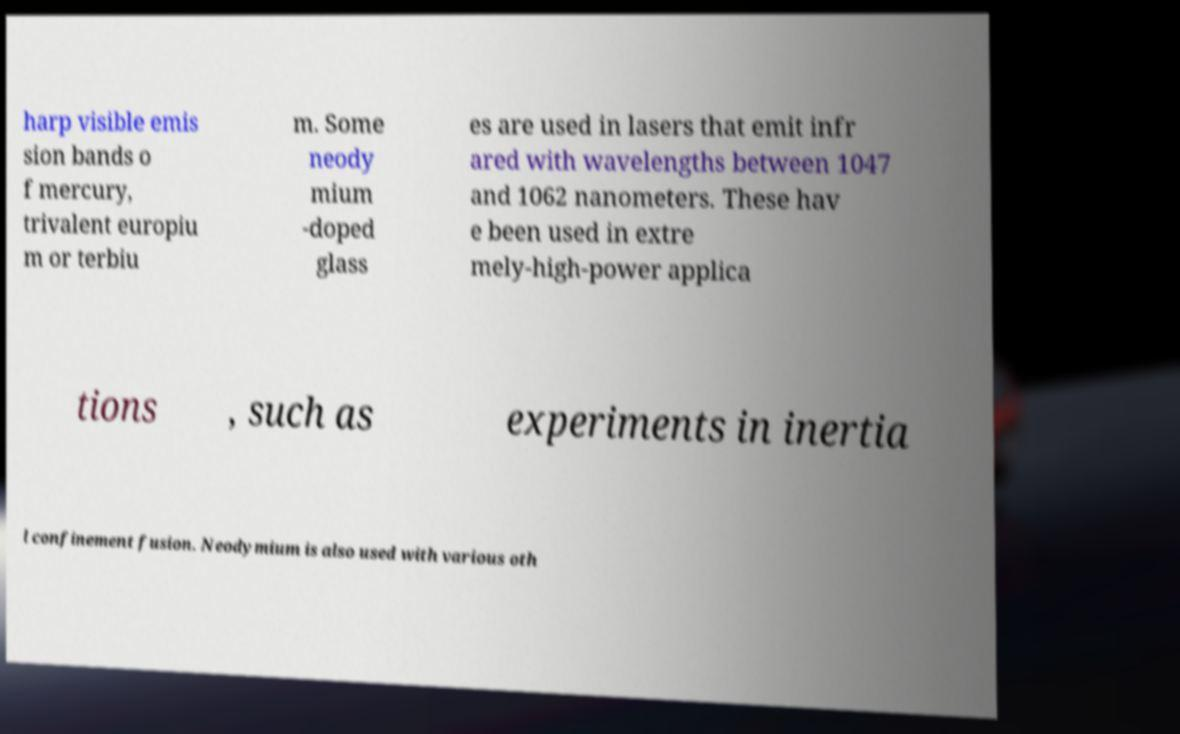Can you read and provide the text displayed in the image?This photo seems to have some interesting text. Can you extract and type it out for me? harp visible emis sion bands o f mercury, trivalent europiu m or terbiu m. Some neody mium -doped glass es are used in lasers that emit infr ared with wavelengths between 1047 and 1062 nanometers. These hav e been used in extre mely-high-power applica tions , such as experiments in inertia l confinement fusion. Neodymium is also used with various oth 